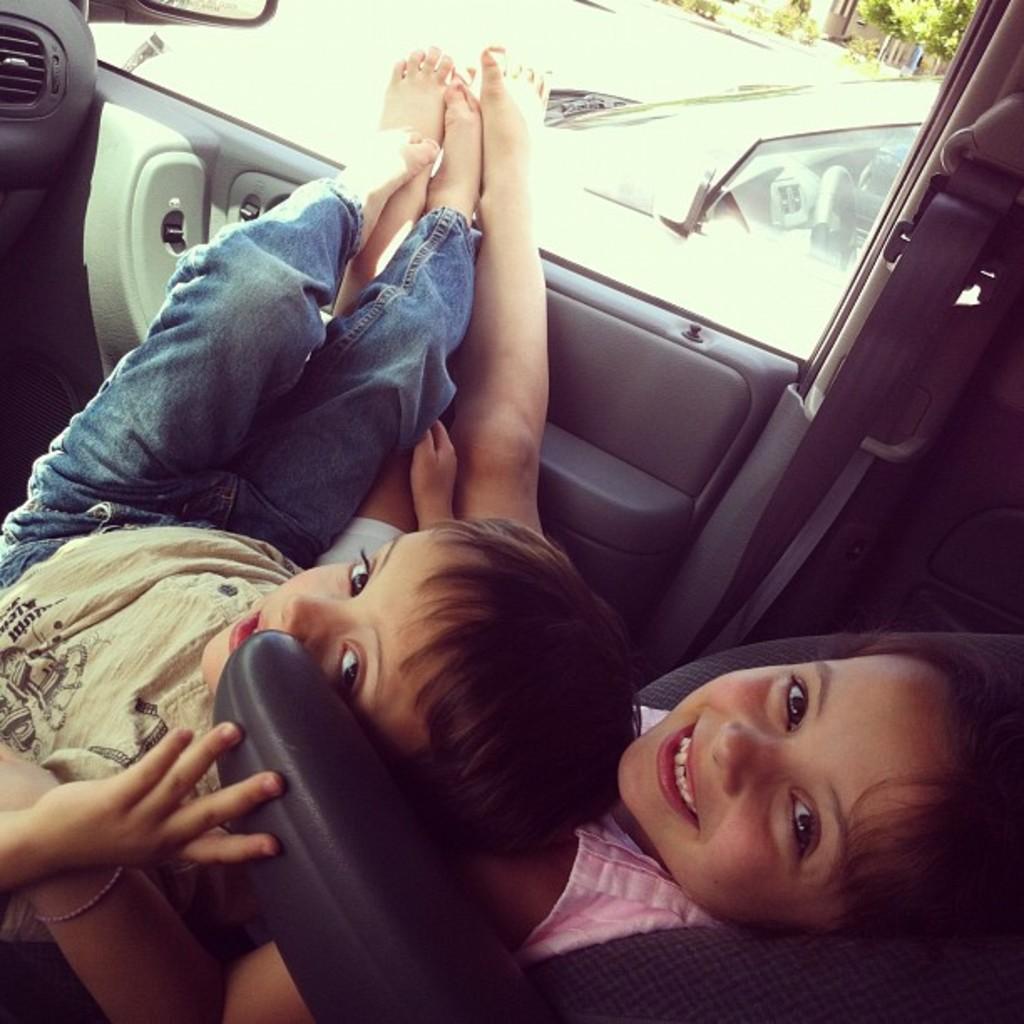Could you give a brief overview of what you see in this image? In this image, two kids are sat on the seat. They are inside the vehicle. they are smiling. The top of the image, we can see few other vehicle, trees, plants, houses. The left side, we can see side mirror. 